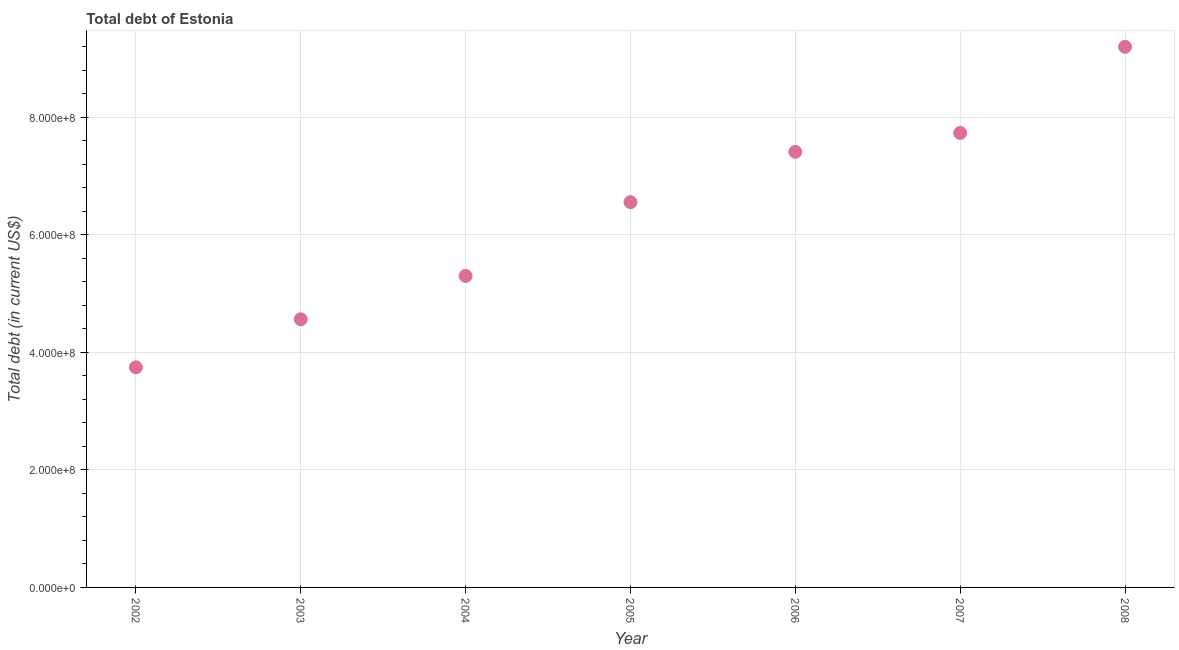What is the total debt in 2003?
Make the answer very short. 4.56e+08. Across all years, what is the maximum total debt?
Your answer should be compact. 9.20e+08. Across all years, what is the minimum total debt?
Your answer should be very brief. 3.75e+08. In which year was the total debt maximum?
Keep it short and to the point. 2008. In which year was the total debt minimum?
Ensure brevity in your answer.  2002. What is the sum of the total debt?
Ensure brevity in your answer.  4.45e+09. What is the difference between the total debt in 2003 and 2008?
Offer a very short reply. -4.64e+08. What is the average total debt per year?
Offer a very short reply. 6.36e+08. What is the median total debt?
Your response must be concise. 6.56e+08. Do a majority of the years between 2003 and 2007 (inclusive) have total debt greater than 40000000 US$?
Make the answer very short. Yes. What is the ratio of the total debt in 2003 to that in 2005?
Give a very brief answer. 0.7. Is the total debt in 2005 less than that in 2008?
Your answer should be very brief. Yes. What is the difference between the highest and the second highest total debt?
Give a very brief answer. 1.47e+08. What is the difference between the highest and the lowest total debt?
Provide a succinct answer. 5.45e+08. How many dotlines are there?
Keep it short and to the point. 1. Does the graph contain any zero values?
Offer a very short reply. No. Does the graph contain grids?
Ensure brevity in your answer.  Yes. What is the title of the graph?
Ensure brevity in your answer.  Total debt of Estonia. What is the label or title of the Y-axis?
Ensure brevity in your answer.  Total debt (in current US$). What is the Total debt (in current US$) in 2002?
Your answer should be very brief. 3.75e+08. What is the Total debt (in current US$) in 2003?
Offer a terse response. 4.56e+08. What is the Total debt (in current US$) in 2004?
Provide a succinct answer. 5.30e+08. What is the Total debt (in current US$) in 2005?
Offer a very short reply. 6.56e+08. What is the Total debt (in current US$) in 2006?
Ensure brevity in your answer.  7.41e+08. What is the Total debt (in current US$) in 2007?
Your answer should be very brief. 7.73e+08. What is the Total debt (in current US$) in 2008?
Give a very brief answer. 9.20e+08. What is the difference between the Total debt (in current US$) in 2002 and 2003?
Offer a very short reply. -8.17e+07. What is the difference between the Total debt (in current US$) in 2002 and 2004?
Your answer should be compact. -1.56e+08. What is the difference between the Total debt (in current US$) in 2002 and 2005?
Offer a very short reply. -2.81e+08. What is the difference between the Total debt (in current US$) in 2002 and 2006?
Ensure brevity in your answer.  -3.67e+08. What is the difference between the Total debt (in current US$) in 2002 and 2007?
Keep it short and to the point. -3.99e+08. What is the difference between the Total debt (in current US$) in 2002 and 2008?
Keep it short and to the point. -5.45e+08. What is the difference between the Total debt (in current US$) in 2003 and 2004?
Keep it short and to the point. -7.38e+07. What is the difference between the Total debt (in current US$) in 2003 and 2005?
Provide a short and direct response. -1.99e+08. What is the difference between the Total debt (in current US$) in 2003 and 2006?
Your answer should be very brief. -2.85e+08. What is the difference between the Total debt (in current US$) in 2003 and 2007?
Make the answer very short. -3.17e+08. What is the difference between the Total debt (in current US$) in 2003 and 2008?
Give a very brief answer. -4.64e+08. What is the difference between the Total debt (in current US$) in 2004 and 2005?
Provide a succinct answer. -1.26e+08. What is the difference between the Total debt (in current US$) in 2004 and 2006?
Your answer should be compact. -2.11e+08. What is the difference between the Total debt (in current US$) in 2004 and 2007?
Your answer should be very brief. -2.43e+08. What is the difference between the Total debt (in current US$) in 2004 and 2008?
Offer a very short reply. -3.90e+08. What is the difference between the Total debt (in current US$) in 2005 and 2006?
Offer a very short reply. -8.56e+07. What is the difference between the Total debt (in current US$) in 2005 and 2007?
Provide a succinct answer. -1.18e+08. What is the difference between the Total debt (in current US$) in 2005 and 2008?
Give a very brief answer. -2.64e+08. What is the difference between the Total debt (in current US$) in 2006 and 2007?
Give a very brief answer. -3.21e+07. What is the difference between the Total debt (in current US$) in 2006 and 2008?
Ensure brevity in your answer.  -1.79e+08. What is the difference between the Total debt (in current US$) in 2007 and 2008?
Your response must be concise. -1.47e+08. What is the ratio of the Total debt (in current US$) in 2002 to that in 2003?
Offer a terse response. 0.82. What is the ratio of the Total debt (in current US$) in 2002 to that in 2004?
Provide a short and direct response. 0.71. What is the ratio of the Total debt (in current US$) in 2002 to that in 2005?
Ensure brevity in your answer.  0.57. What is the ratio of the Total debt (in current US$) in 2002 to that in 2006?
Provide a short and direct response. 0.51. What is the ratio of the Total debt (in current US$) in 2002 to that in 2007?
Your answer should be very brief. 0.48. What is the ratio of the Total debt (in current US$) in 2002 to that in 2008?
Ensure brevity in your answer.  0.41. What is the ratio of the Total debt (in current US$) in 2003 to that in 2004?
Keep it short and to the point. 0.86. What is the ratio of the Total debt (in current US$) in 2003 to that in 2005?
Offer a terse response. 0.7. What is the ratio of the Total debt (in current US$) in 2003 to that in 2006?
Offer a very short reply. 0.62. What is the ratio of the Total debt (in current US$) in 2003 to that in 2007?
Your response must be concise. 0.59. What is the ratio of the Total debt (in current US$) in 2003 to that in 2008?
Provide a succinct answer. 0.5. What is the ratio of the Total debt (in current US$) in 2004 to that in 2005?
Your answer should be compact. 0.81. What is the ratio of the Total debt (in current US$) in 2004 to that in 2006?
Your response must be concise. 0.71. What is the ratio of the Total debt (in current US$) in 2004 to that in 2007?
Offer a very short reply. 0.69. What is the ratio of the Total debt (in current US$) in 2004 to that in 2008?
Offer a terse response. 0.58. What is the ratio of the Total debt (in current US$) in 2005 to that in 2006?
Make the answer very short. 0.89. What is the ratio of the Total debt (in current US$) in 2005 to that in 2007?
Make the answer very short. 0.85. What is the ratio of the Total debt (in current US$) in 2005 to that in 2008?
Provide a short and direct response. 0.71. What is the ratio of the Total debt (in current US$) in 2006 to that in 2007?
Your answer should be compact. 0.96. What is the ratio of the Total debt (in current US$) in 2006 to that in 2008?
Offer a terse response. 0.81. What is the ratio of the Total debt (in current US$) in 2007 to that in 2008?
Ensure brevity in your answer.  0.84. 